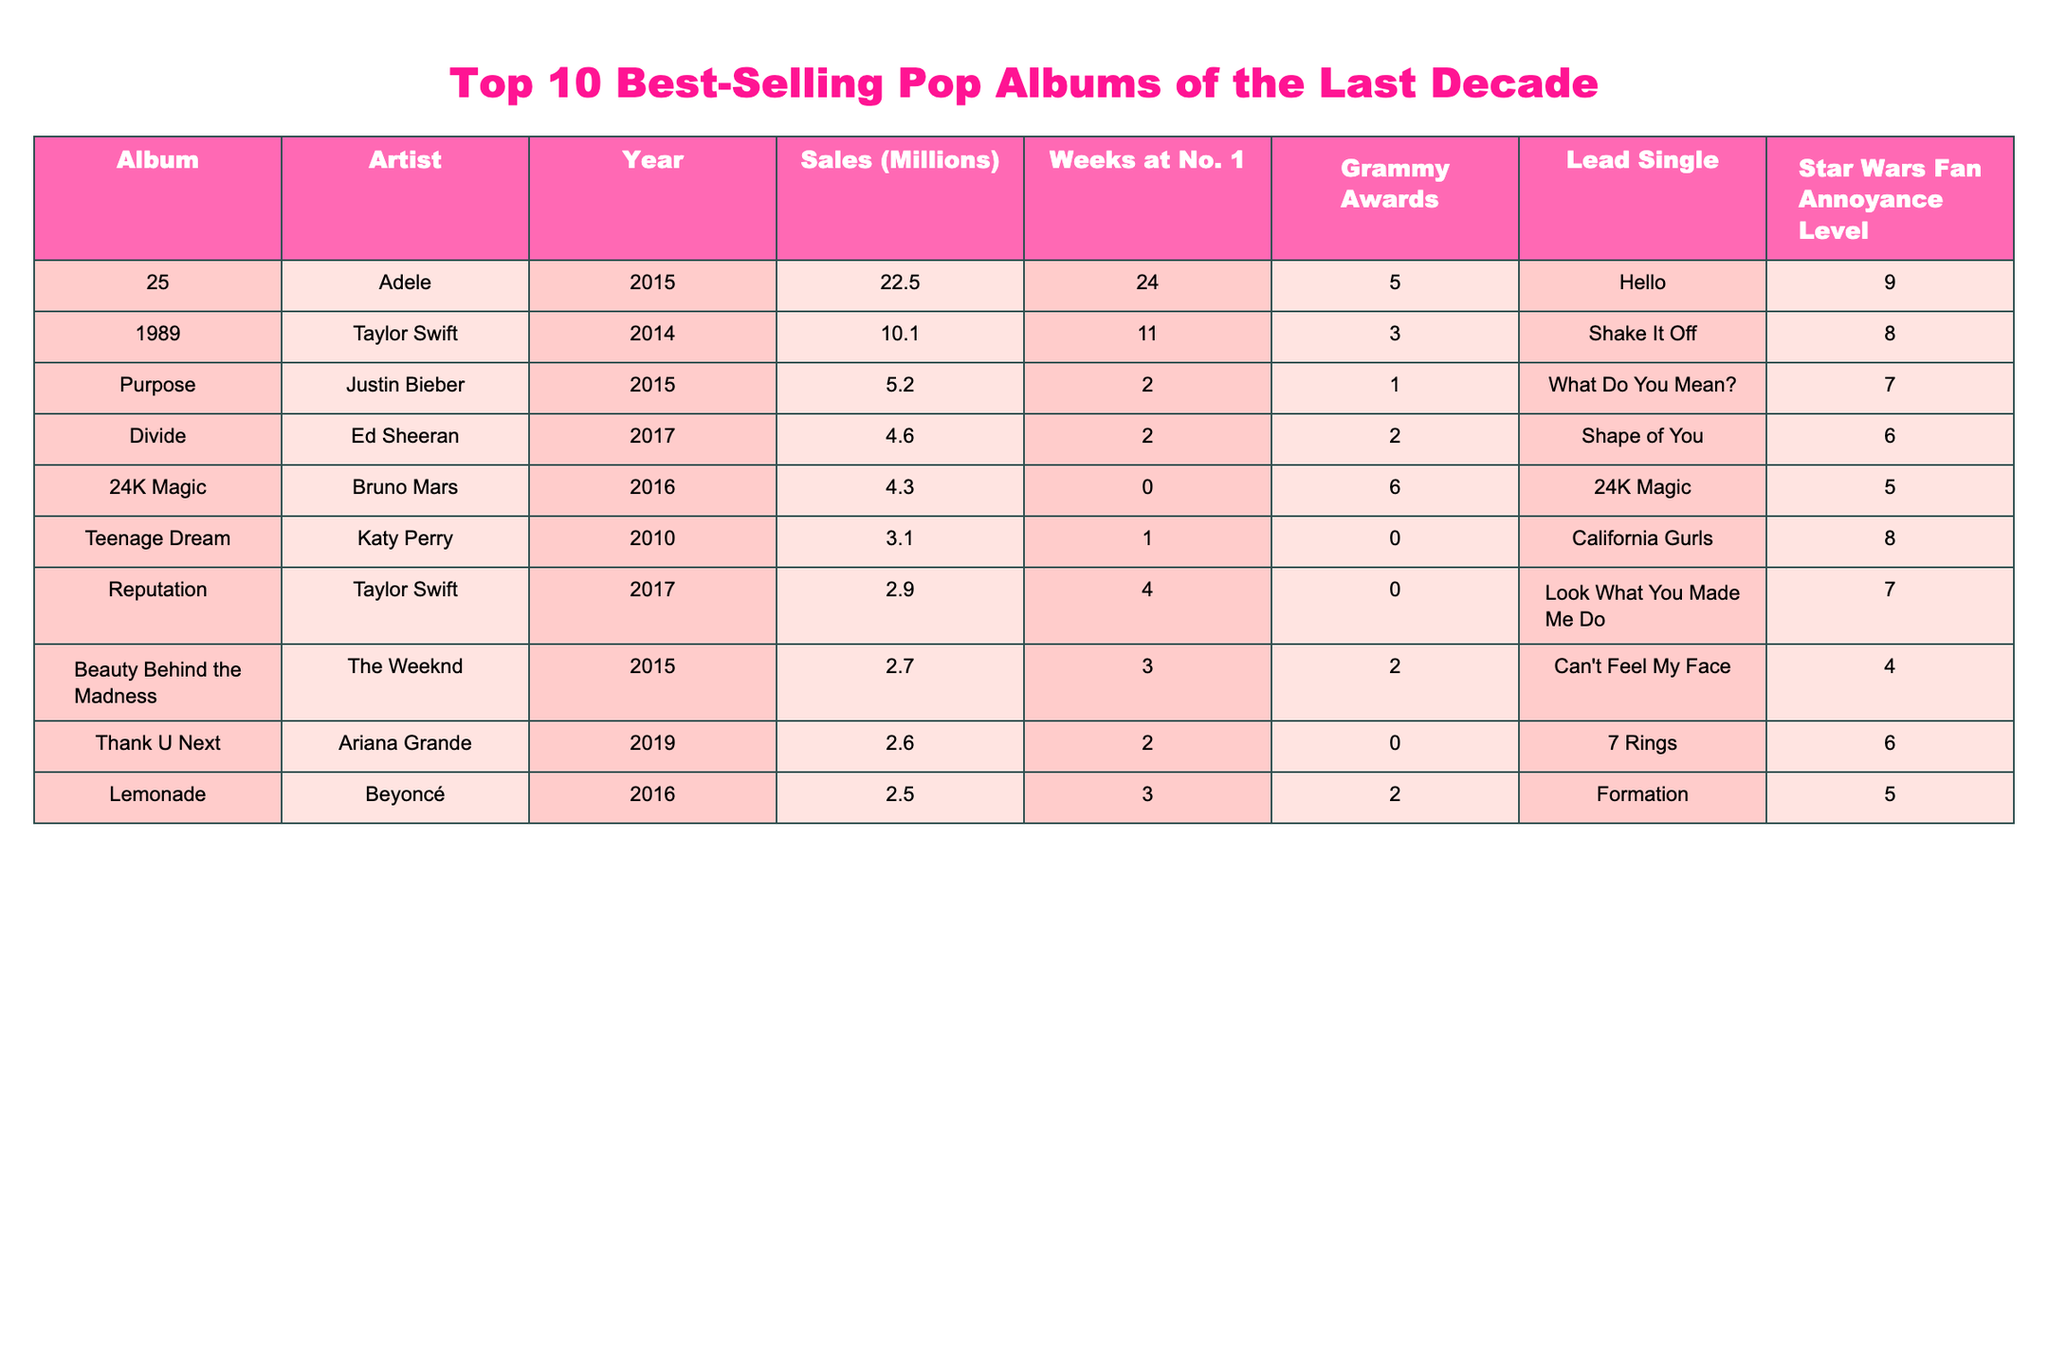What is the best-selling pop album of the last decade? The highest sales figure in the table is 22.5 million, which corresponds to Adele's album "25."
Answer: 25 Which artist has the album with the most Grammy Awards? Adele's "25" has the most Grammy Awards at 5.
Answer: Adele How many weeks did Taylor Swift's "1989" spend at number one? The table shows "1989" spent 11 weeks at number one, which is specified in that row.
Answer: 11 weeks What is the total sales for Ed Sheeran's "Divide" and Katy Perry's "Teenage Dream"? "Divide" has sales of 4.6 million, and "Teenage Dream" has 3.1 million, so the total is 4.6 + 3.1 = 7.7 million.
Answer: 7.7 million Which album has a star wars fan annoyance level of 6? The table indicates that both Ed Sheeran's "Divide" and Ariana Grande's "Thank U, Next" have an annoyance level of 6.
Answer: Divide, Thank U Next Did any album sell less than 3 million copies? Yes, the albums "Thank U Next," "Lemonade," "Beauty Behind the Madness," and "Reputation" each sold less than 3 million copies.
Answer: Yes What is the average sales of the albums listed for artists with Grammy Awards? The albums with Grammy Awards are "25" (22.5M), "1989" (10.1M), "Purpose" (5.2M), "Divide" (4.6M), "24K Magic" (4.3M), "Beauty Behind the Madness" (2.7M), and "Lemonade" (2.5M). The sum is 22.5 + 10.1 + 5.2 + 4.6 + 4.3 + 2.7 + 2.5 = 52.9 million. There are 7 albums, so the average is 52.9 / 7 ≈ 7.57 million.
Answer: Approximately 7.57 million Which albums spent more than 2 weeks at number one? The albums with over 2 weeks at number one are "25" (24 weeks) and "1989" (11 weeks).
Answer: 25, 1989 Identify the artist with the lowest star wars fan annoyance level. The lowest annoyance level listed in the table is 5, which corresponds to Bruno Mars' album "24K Magic" and Beyoncé's "Lemonade."
Answer: Bruno Mars, Beyoncé What is the difference in sales between Adele's "25" and Justin Bieber's "Purpose"? "25" sold 22.5 million and "Purpose" sold 5.2 million. The difference in sales is 22.5 - 5.2 = 17.3 million.
Answer: 17.3 million 